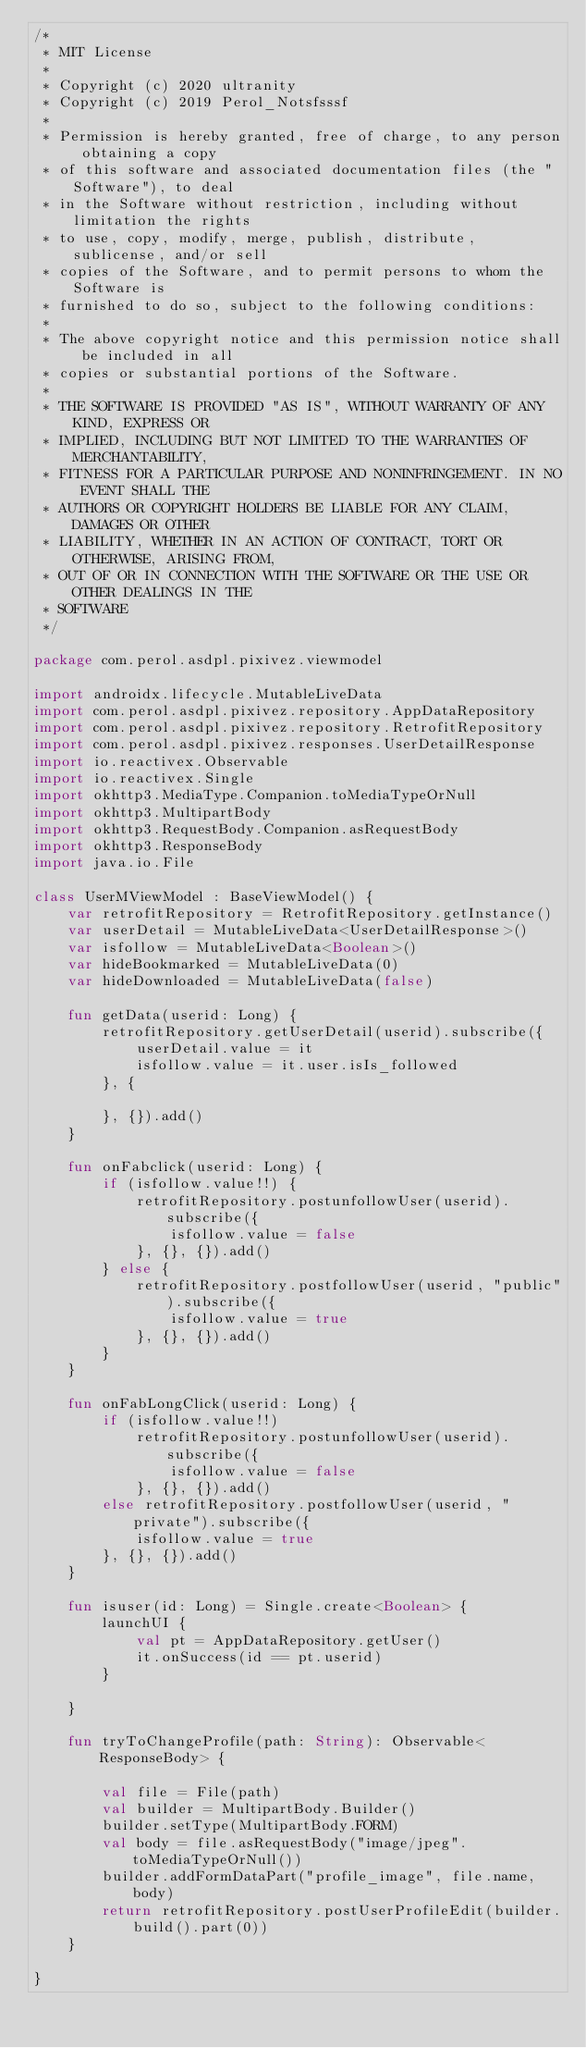<code> <loc_0><loc_0><loc_500><loc_500><_Kotlin_>/*
 * MIT License
 *
 * Copyright (c) 2020 ultranity
 * Copyright (c) 2019 Perol_Notsfsssf
 *
 * Permission is hereby granted, free of charge, to any person obtaining a copy
 * of this software and associated documentation files (the "Software"), to deal
 * in the Software without restriction, including without limitation the rights
 * to use, copy, modify, merge, publish, distribute, sublicense, and/or sell
 * copies of the Software, and to permit persons to whom the Software is
 * furnished to do so, subject to the following conditions:
 *
 * The above copyright notice and this permission notice shall be included in all
 * copies or substantial portions of the Software.
 *
 * THE SOFTWARE IS PROVIDED "AS IS", WITHOUT WARRANTY OF ANY KIND, EXPRESS OR
 * IMPLIED, INCLUDING BUT NOT LIMITED TO THE WARRANTIES OF MERCHANTABILITY,
 * FITNESS FOR A PARTICULAR PURPOSE AND NONINFRINGEMENT. IN NO EVENT SHALL THE
 * AUTHORS OR COPYRIGHT HOLDERS BE LIABLE FOR ANY CLAIM, DAMAGES OR OTHER
 * LIABILITY, WHETHER IN AN ACTION OF CONTRACT, TORT OR OTHERWISE, ARISING FROM,
 * OUT OF OR IN CONNECTION WITH THE SOFTWARE OR THE USE OR OTHER DEALINGS IN THE
 * SOFTWARE
 */

package com.perol.asdpl.pixivez.viewmodel

import androidx.lifecycle.MutableLiveData
import com.perol.asdpl.pixivez.repository.AppDataRepository
import com.perol.asdpl.pixivez.repository.RetrofitRepository
import com.perol.asdpl.pixivez.responses.UserDetailResponse
import io.reactivex.Observable
import io.reactivex.Single
import okhttp3.MediaType.Companion.toMediaTypeOrNull
import okhttp3.MultipartBody
import okhttp3.RequestBody.Companion.asRequestBody
import okhttp3.ResponseBody
import java.io.File

class UserMViewModel : BaseViewModel() {
    var retrofitRepository = RetrofitRepository.getInstance()
    var userDetail = MutableLiveData<UserDetailResponse>()
    var isfollow = MutableLiveData<Boolean>()
    var hideBookmarked = MutableLiveData(0)
    var hideDownloaded = MutableLiveData(false)

    fun getData(userid: Long) {
        retrofitRepository.getUserDetail(userid).subscribe({
            userDetail.value = it
            isfollow.value = it.user.isIs_followed
        }, {

        }, {}).add()
    }

    fun onFabclick(userid: Long) {
        if (isfollow.value!!) {
            retrofitRepository.postunfollowUser(userid).subscribe({
                isfollow.value = false
            }, {}, {}).add()
        } else {
            retrofitRepository.postfollowUser(userid, "public").subscribe({
                isfollow.value = true
            }, {}, {}).add()
        }
    }

    fun onFabLongClick(userid: Long) {
        if (isfollow.value!!)
            retrofitRepository.postunfollowUser(userid).subscribe({
                isfollow.value = false
            }, {}, {}).add()
        else retrofitRepository.postfollowUser(userid, "private").subscribe({
            isfollow.value = true
        }, {}, {}).add()
    }

    fun isuser(id: Long) = Single.create<Boolean> {
        launchUI {
            val pt = AppDataRepository.getUser()
            it.onSuccess(id == pt.userid)
        }

    }

    fun tryToChangeProfile(path: String): Observable<ResponseBody> {

        val file = File(path)
        val builder = MultipartBody.Builder()
        builder.setType(MultipartBody.FORM)
        val body = file.asRequestBody("image/jpeg".toMediaTypeOrNull())
        builder.addFormDataPart("profile_image", file.name, body)
        return retrofitRepository.postUserProfileEdit(builder.build().part(0))
    }

}</code> 